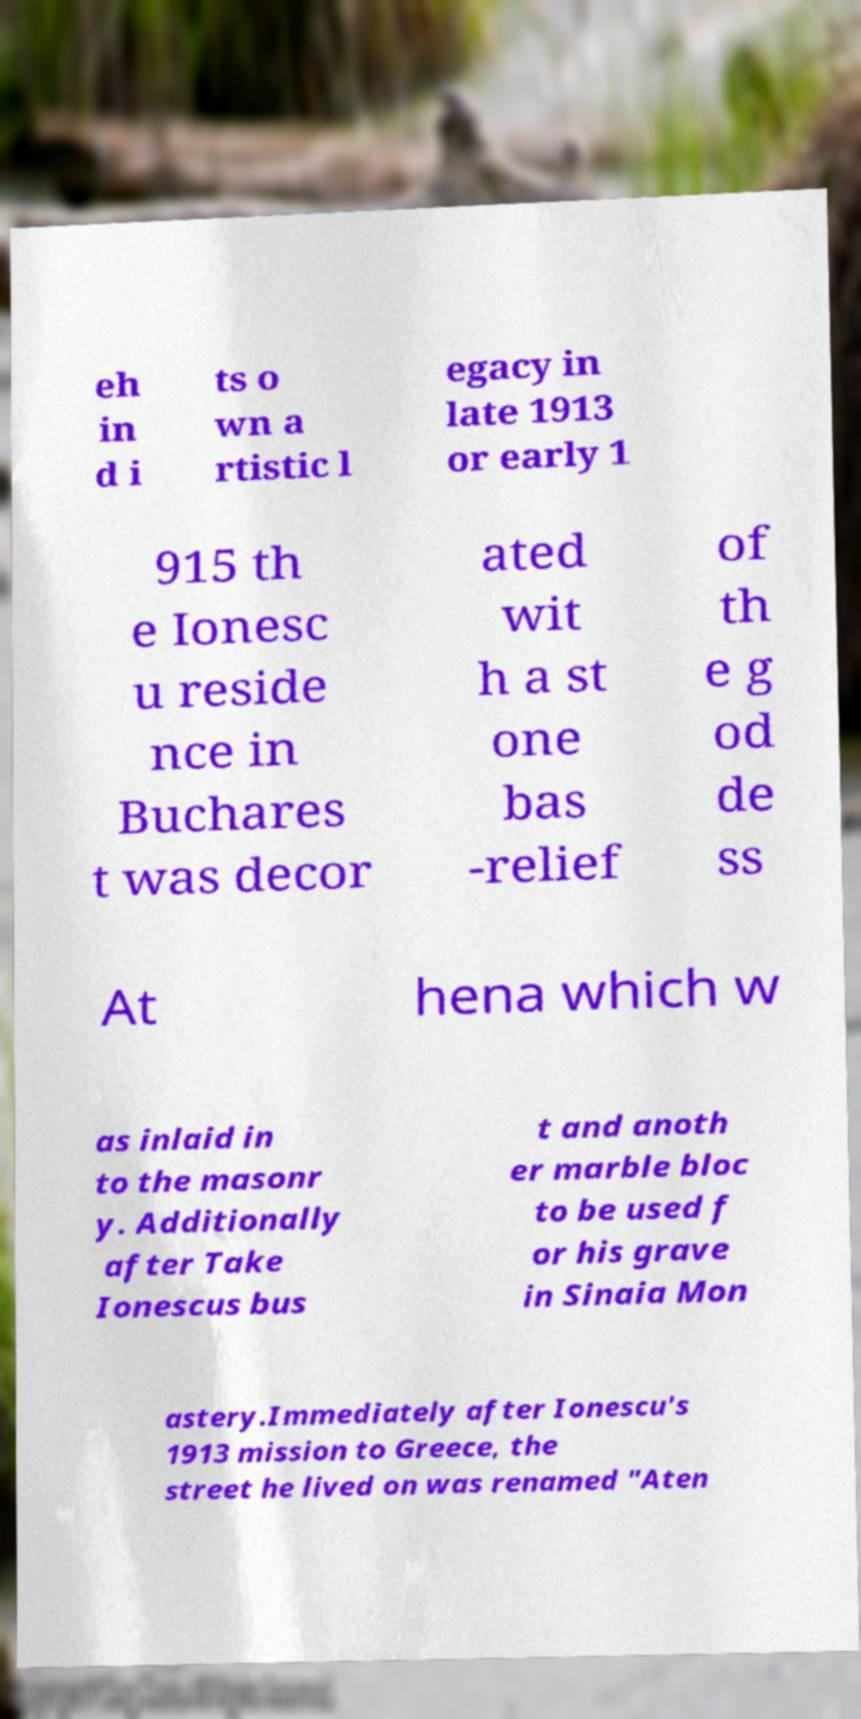Please read and relay the text visible in this image. What does it say? eh in d i ts o wn a rtistic l egacy in late 1913 or early 1 915 th e Ionesc u reside nce in Buchares t was decor ated wit h a st one bas -relief of th e g od de ss At hena which w as inlaid in to the masonr y. Additionally after Take Ionescus bus t and anoth er marble bloc to be used f or his grave in Sinaia Mon astery.Immediately after Ionescu's 1913 mission to Greece, the street he lived on was renamed "Aten 